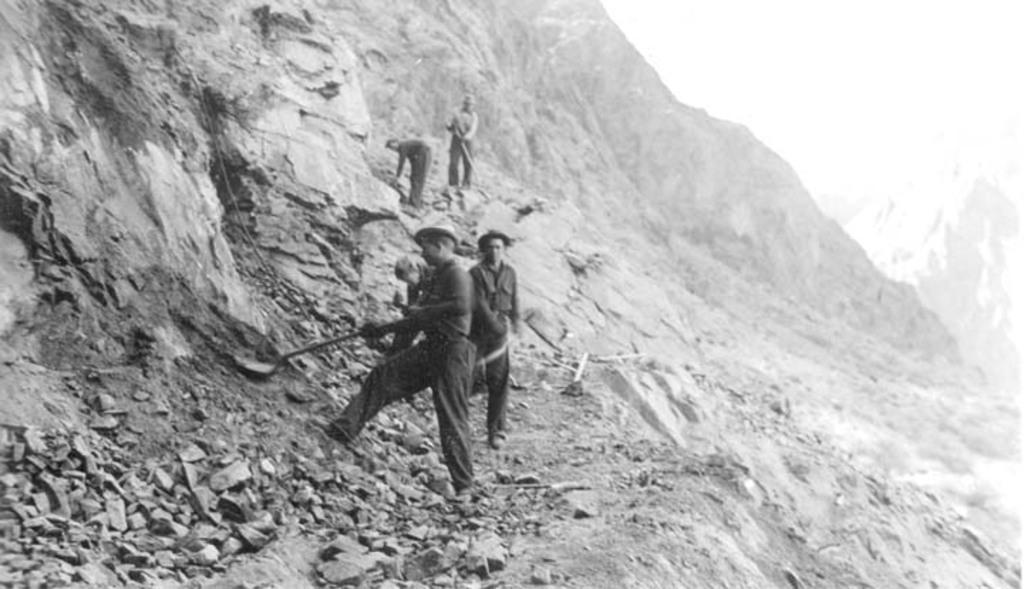Describe this image in one or two sentences. In this image I can see few people are standing and in the front I can see one of them is holding a spade. I can also see number of stones on the bottom left side and I can see this image is black and white in colour. 